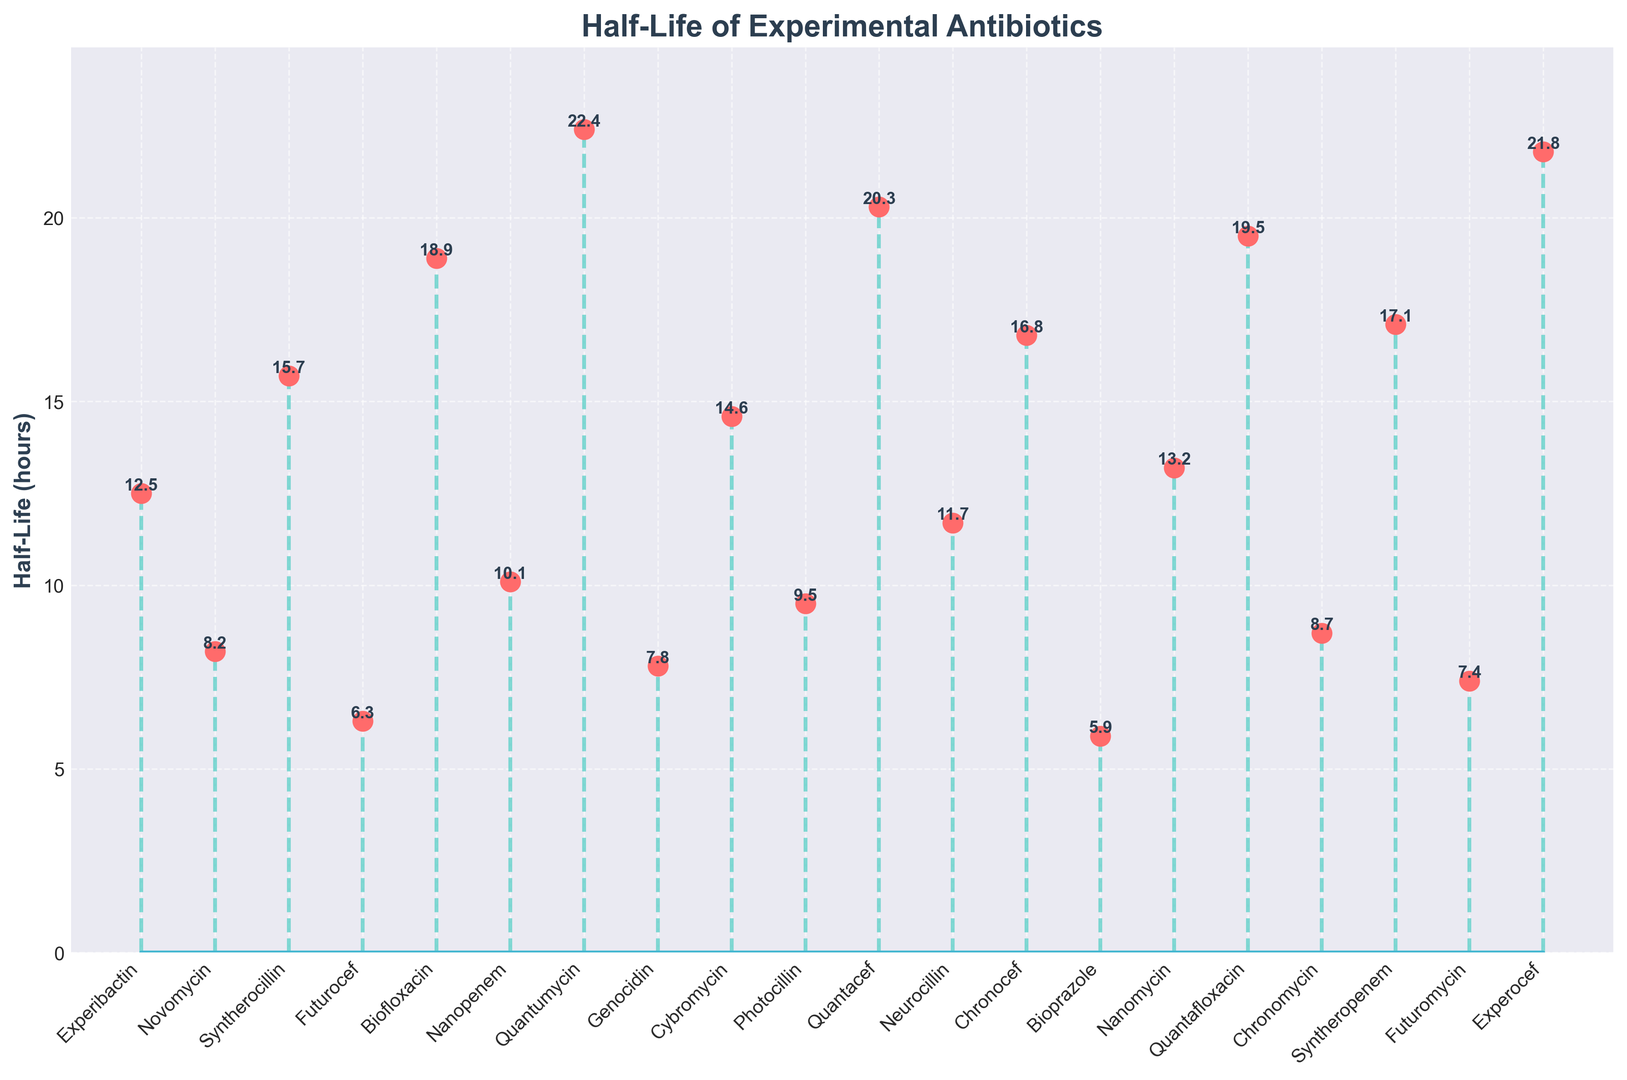What is the half-life of Biofloxacin? Biofloxacin is directly labeled above its corresponding marker, showing a value of 18.9.
Answer: 18.9 Which drug has the highest half-life? Quantumycin has the highest marker among all drugs, with a value of 22.4.
Answer: Quantumycin How many drugs have a half-life greater than 15 hours? Identifying markers that are above the horizontal line at 15, we count Experocef (21.8), Quantumycin (22.4), Quantacef (20.3), Quantafloxacin (19.5), Biofloxacin (18.9), Syntheropenem (17.1), and Chronocef (16.8).
Answer: 7 What is the total half-life of Novomycin and Futurocef combined? Novomycin has a half-life of 8.2, and Futurocef has 6.3, their sum is 8.2 + 6.3 = 14.5.
Answer: 14.5 Are there more drugs with a half-life less than 10 hours or more than 15 hours? Count the drugs with half-lives less than 10 (Novomycin, Futurocef, Genocidin, Photocillin, Bioprazole, Chronomycin, Futuromycin) which total to 7, and count those more than 15 (Experocef, Quantumycin, Quantacef, Quantafloxacin, Biofloxacin, Syntheropenem, Chronocef, Syntherocillin) which total to 8.
Answer: More than 15 hours How does the half-life of Experibactin compare to Neurocillin? Experibactin has a value of 12.5, and Neurocillin has 11.7. 12.5 is greater than 11.7.
Answer: Experibactin has a higher half-life What is the difference in half-life between Cybromycin and Bioprazole? Cybromycin's half-life is 14.6 and Bioprazole's is 5.9. The difference is 14.6 - 5.9 = 8.7.
Answer: 8.7 Which drug has the lowest half-life? Bioprazole has the lowest marker value at 5.9.
Answer: Bioprazole What is the average half-life of all drugs? Sum all half-life values (12.5+8.2+15.7+6.3+18.9+10.1+22.4+7.8+14.6+9.5+20.3+11.7+16.8+5.9+13.2+19.5+8.7+17.1+7.4+21.8 = 268.4). There are 20 drugs, so the average is 268.4/20 = 13.42.
Answer: 13.42 